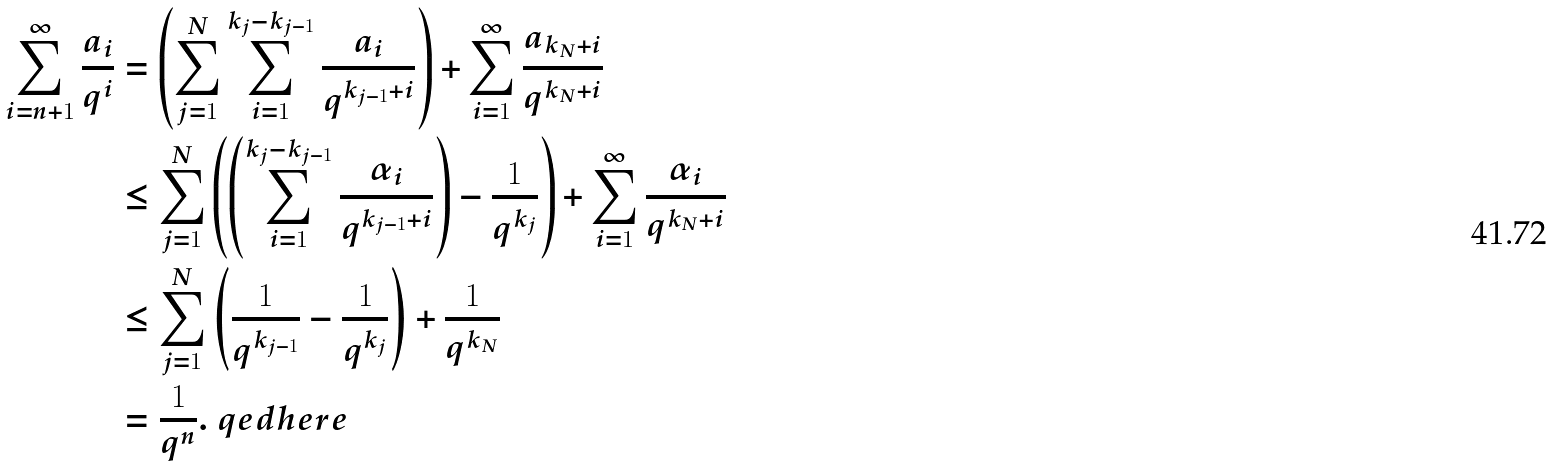Convert formula to latex. <formula><loc_0><loc_0><loc_500><loc_500>\sum _ { i = n + 1 } ^ { \infty } \frac { a _ { i } } { q ^ { i } } & = \left ( \sum _ { j = 1 } ^ { N } \sum _ { i = 1 } ^ { k _ { j } - k _ { j - 1 } } \frac { a _ { i } } { q ^ { k _ { j - 1 } + i } } \right ) + \sum _ { i = 1 } ^ { \infty } \frac { a _ { k _ { N } + i } } { q ^ { k _ { N } + i } } \\ & \leq \sum _ { j = 1 } ^ { N } \left ( \left ( \sum _ { i = 1 } ^ { k _ { j } - k _ { j - 1 } } \frac { \alpha _ { i } } { q ^ { k _ { j - 1 } + i } } \right ) - \frac { 1 } { q ^ { k _ { j } } } \right ) + \sum _ { i = 1 } ^ { \infty } \frac { \alpha _ { i } } { q ^ { k _ { N } + i } } \\ & \leq \sum _ { j = 1 } ^ { N } \left ( \frac { 1 } { q ^ { k _ { j - 1 } } } - \frac { 1 } { q ^ { k _ { j } } } \right ) + \frac { 1 } { q ^ { k _ { N } } } \\ & = \frac { 1 } { q ^ { n } } . \ q e d h e r e</formula> 